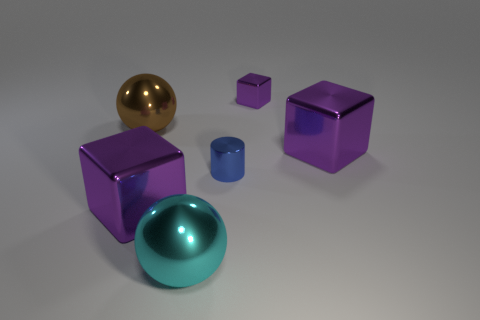Add 2 big brown shiny balls. How many objects exist? 8 Subtract all cylinders. How many objects are left? 5 Subtract all green balls. Subtract all tiny blue things. How many objects are left? 5 Add 1 small cylinders. How many small cylinders are left? 2 Add 3 tiny brown matte cylinders. How many tiny brown matte cylinders exist? 3 Subtract 0 gray cylinders. How many objects are left? 6 